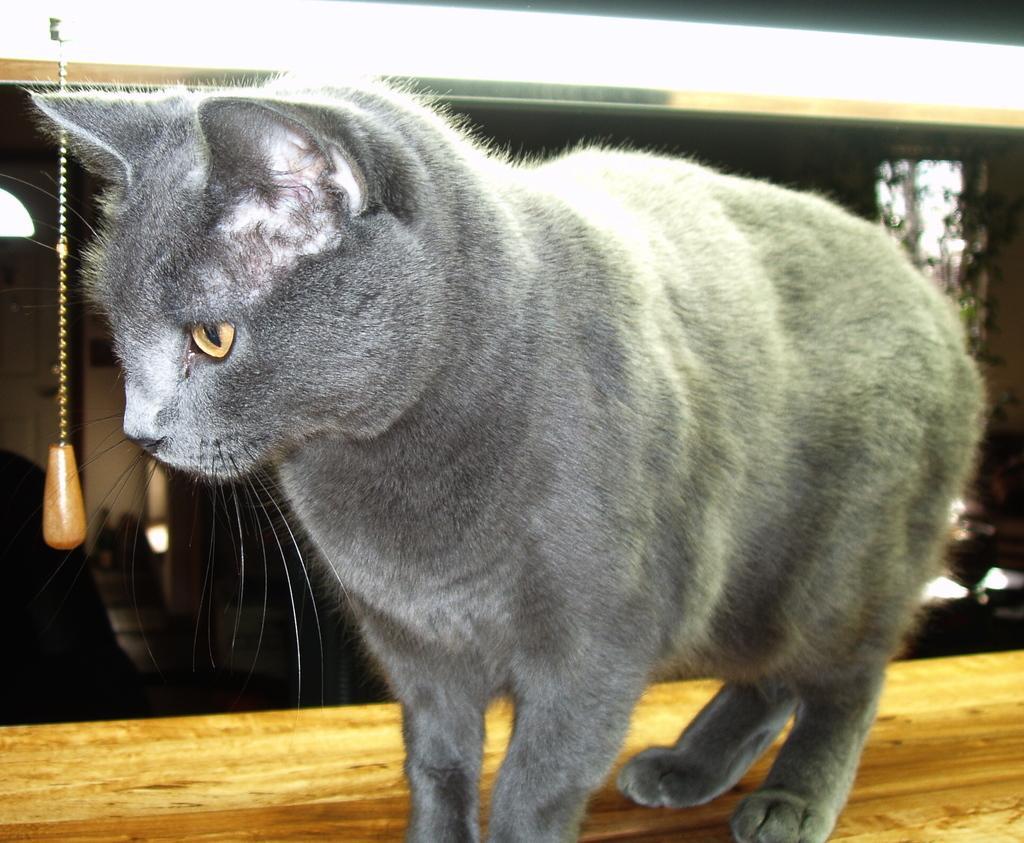How would you summarize this image in a sentence or two? In the image there is a grey color cat on the wooden surface. At the top of the image there is a light. 